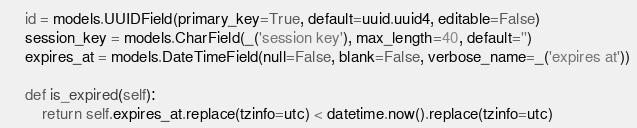Convert code to text. <code><loc_0><loc_0><loc_500><loc_500><_Python_>    id = models.UUIDField(primary_key=True, default=uuid.uuid4, editable=False)
    session_key = models.CharField(_('session key'), max_length=40, default='')
    expires_at = models.DateTimeField(null=False, blank=False, verbose_name=_('expires at'))

    def is_expired(self):
        return self.expires_at.replace(tzinfo=utc) < datetime.now().replace(tzinfo=utc)
</code> 